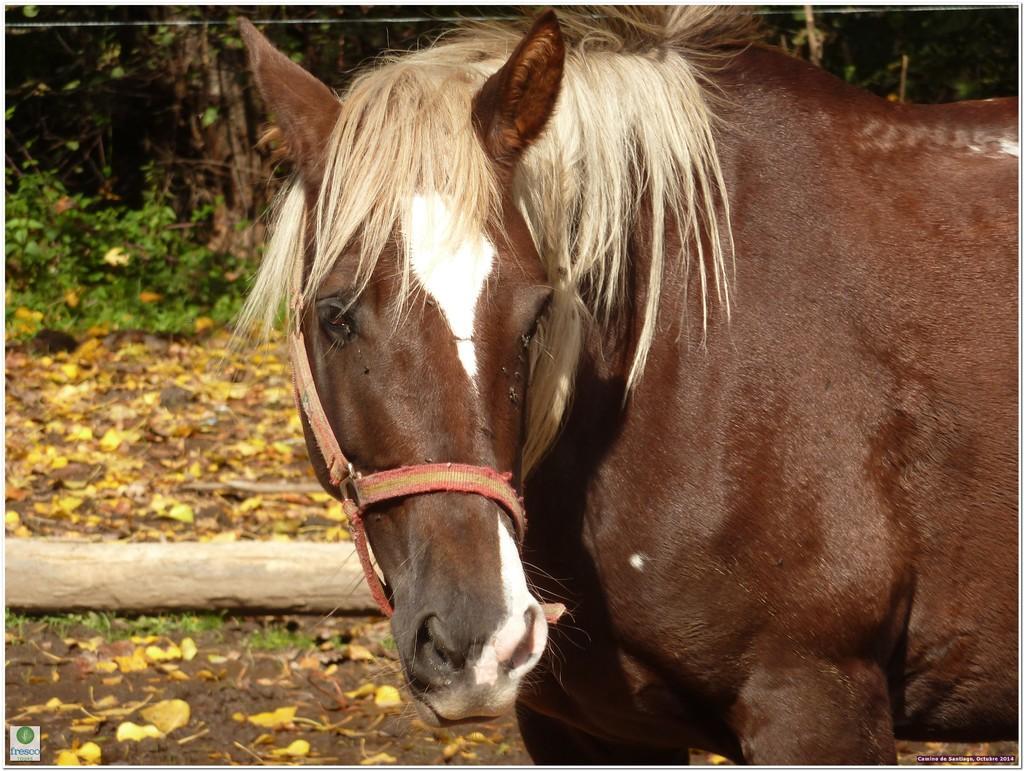How would you summarize this image in a sentence or two? In this image, I can see a horse standing. This looks like a wooden branch. I can see the leaves on the ground. In the background, these look like the plants. At the bottom left corner of the image, I can see the watermark. 